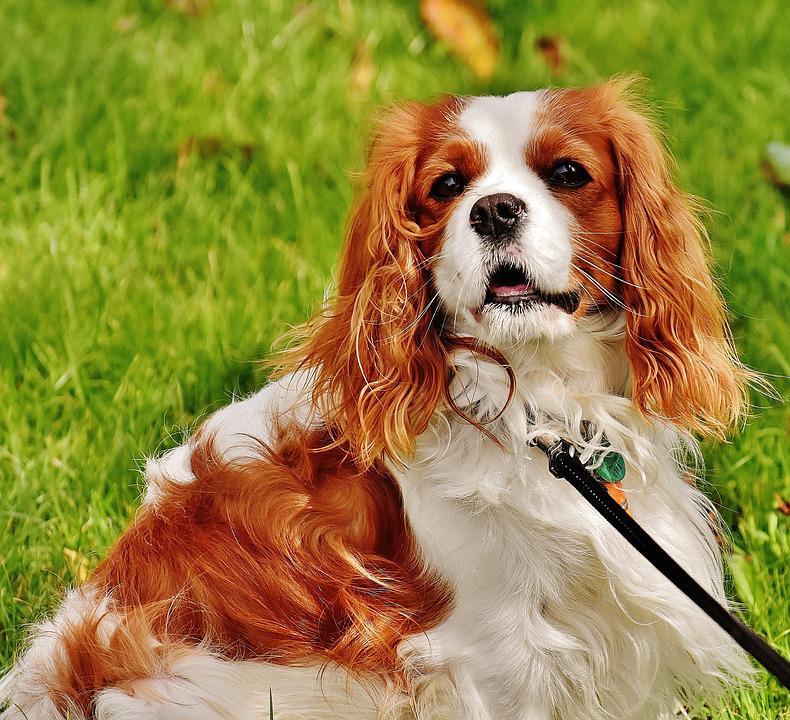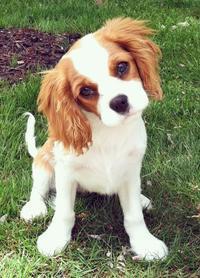The first image is the image on the left, the second image is the image on the right. Analyze the images presented: Is the assertion "The dog on the left is sitting on the grass." valid? Answer yes or no. Yes. 